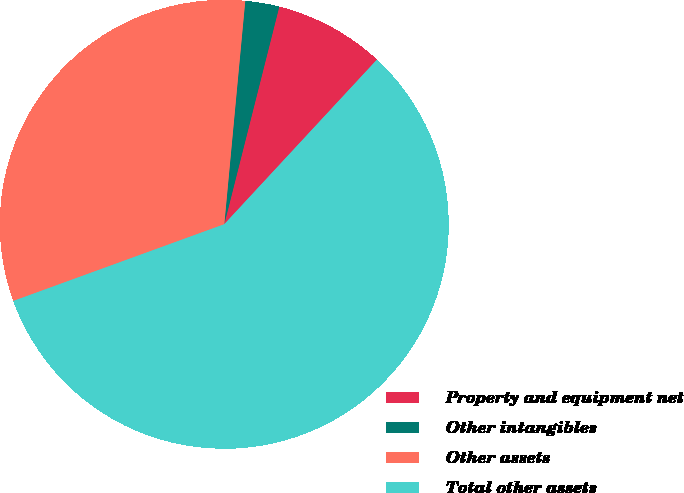<chart> <loc_0><loc_0><loc_500><loc_500><pie_chart><fcel>Property and equipment net<fcel>Other intangibles<fcel>Other assets<fcel>Total other assets<nl><fcel>7.96%<fcel>2.45%<fcel>32.04%<fcel>57.54%<nl></chart> 